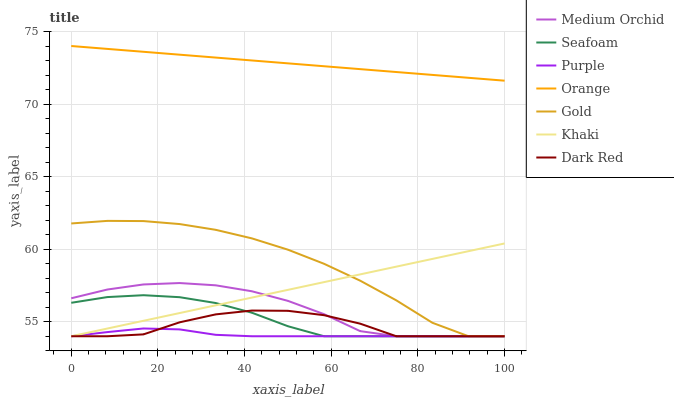Does Purple have the minimum area under the curve?
Answer yes or no. Yes. Does Orange have the maximum area under the curve?
Answer yes or no. Yes. Does Gold have the minimum area under the curve?
Answer yes or no. No. Does Gold have the maximum area under the curve?
Answer yes or no. No. Is Orange the smoothest?
Answer yes or no. Yes. Is Dark Red the roughest?
Answer yes or no. Yes. Is Gold the smoothest?
Answer yes or no. No. Is Gold the roughest?
Answer yes or no. No. Does Khaki have the lowest value?
Answer yes or no. Yes. Does Orange have the lowest value?
Answer yes or no. No. Does Orange have the highest value?
Answer yes or no. Yes. Does Gold have the highest value?
Answer yes or no. No. Is Medium Orchid less than Orange?
Answer yes or no. Yes. Is Orange greater than Dark Red?
Answer yes or no. Yes. Does Khaki intersect Gold?
Answer yes or no. Yes. Is Khaki less than Gold?
Answer yes or no. No. Is Khaki greater than Gold?
Answer yes or no. No. Does Medium Orchid intersect Orange?
Answer yes or no. No. 